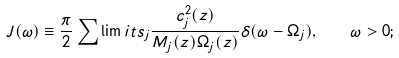Convert formula to latex. <formula><loc_0><loc_0><loc_500><loc_500>J ( \omega ) \equiv \frac { \pi } { 2 } \sum \lim i t s _ { j } \frac { c _ { j } ^ { 2 } ( { z } ) } { M _ { j } ( { z } ) \Omega _ { j } ( { z } ) } \delta ( \omega - \Omega _ { j } ) , \quad \omega > 0 ;</formula> 